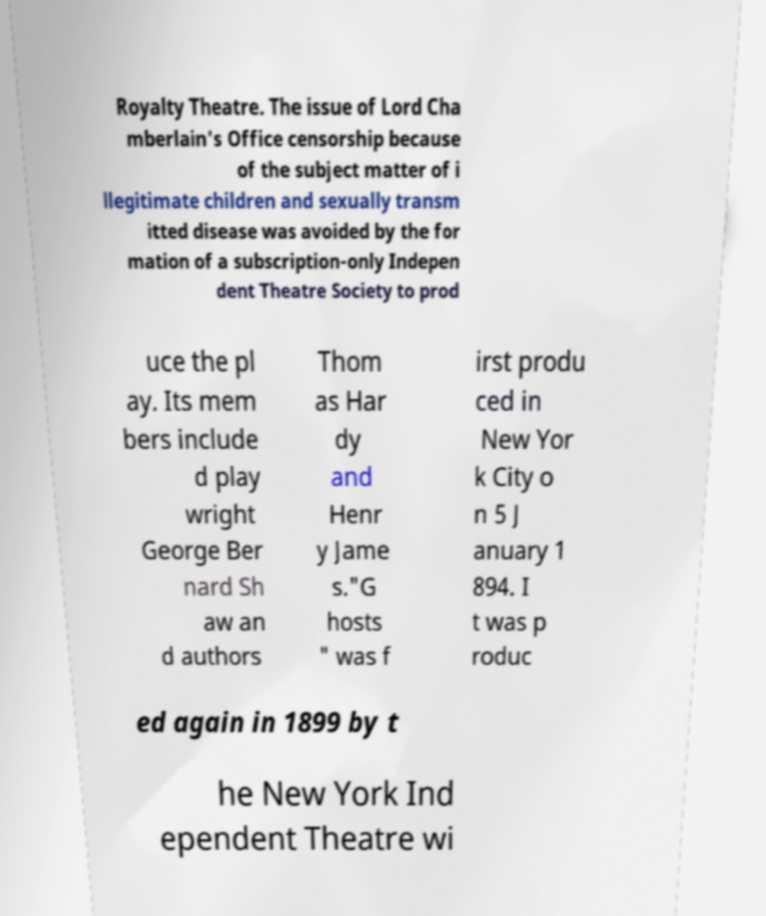Can you read and provide the text displayed in the image?This photo seems to have some interesting text. Can you extract and type it out for me? Royalty Theatre. The issue of Lord Cha mberlain's Office censorship because of the subject matter of i llegitimate children and sexually transm itted disease was avoided by the for mation of a subscription-only Indepen dent Theatre Society to prod uce the pl ay. Its mem bers include d play wright George Ber nard Sh aw an d authors Thom as Har dy and Henr y Jame s."G hosts " was f irst produ ced in New Yor k City o n 5 J anuary 1 894. I t was p roduc ed again in 1899 by t he New York Ind ependent Theatre wi 